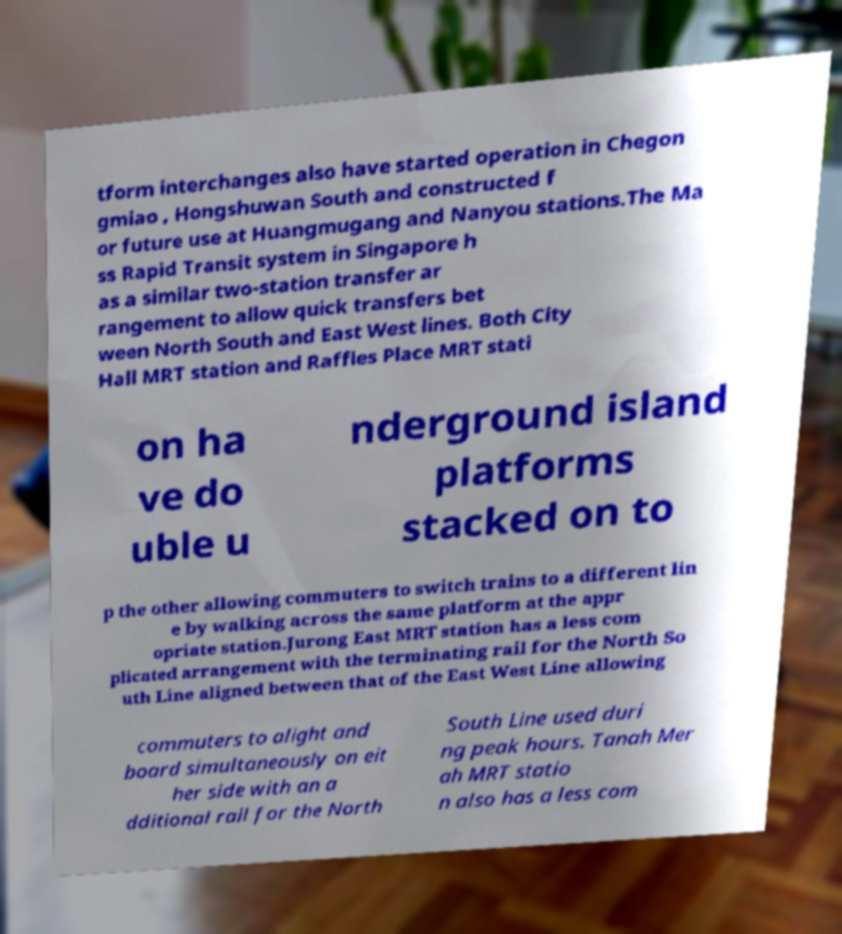I need the written content from this picture converted into text. Can you do that? tform interchanges also have started operation in Chegon gmiao , Hongshuwan South and constructed f or future use at Huangmugang and Nanyou stations.The Ma ss Rapid Transit system in Singapore h as a similar two-station transfer ar rangement to allow quick transfers bet ween North South and East West lines. Both City Hall MRT station and Raffles Place MRT stati on ha ve do uble u nderground island platforms stacked on to p the other allowing commuters to switch trains to a different lin e by walking across the same platform at the appr opriate station.Jurong East MRT station has a less com plicated arrangement with the terminating rail for the North So uth Line aligned between that of the East West Line allowing commuters to alight and board simultaneously on eit her side with an a dditional rail for the North South Line used duri ng peak hours. Tanah Mer ah MRT statio n also has a less com 